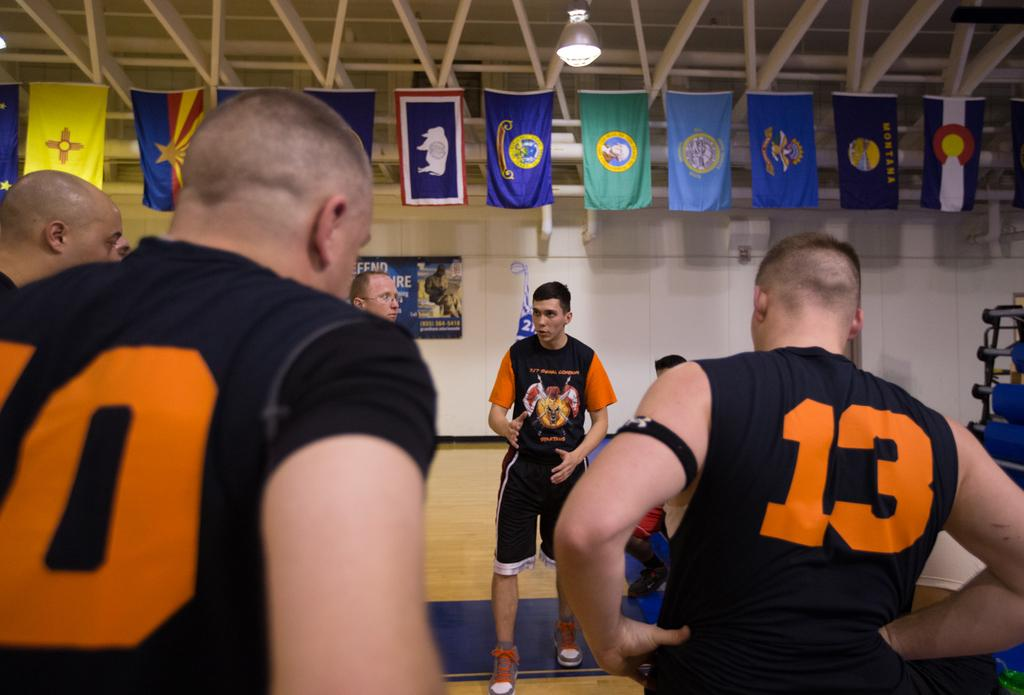<image>
Offer a succinct explanation of the picture presented. Athletes wearing number 10 and number 13 listening to someone speaking. 